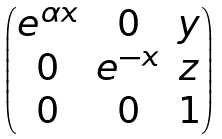Convert formula to latex. <formula><loc_0><loc_0><loc_500><loc_500>\begin{pmatrix} e ^ { \alpha x } & 0 & y \\ 0 & e ^ { - x } & z \\ 0 & 0 & 1 \end{pmatrix}</formula> 